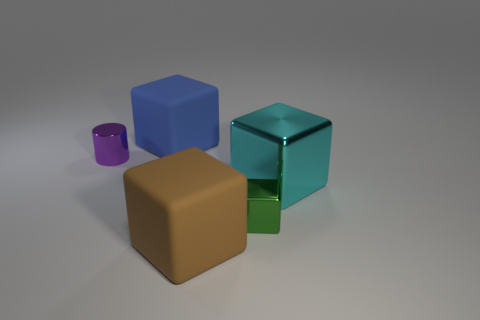Subtract 1 cubes. How many cubes are left? 3 Add 5 green things. How many objects exist? 10 Subtract all blocks. How many objects are left? 1 Subtract 0 blue balls. How many objects are left? 5 Subtract all purple metal objects. Subtract all blue rubber things. How many objects are left? 3 Add 3 big cyan objects. How many big cyan objects are left? 4 Add 2 purple metallic cylinders. How many purple metallic cylinders exist? 3 